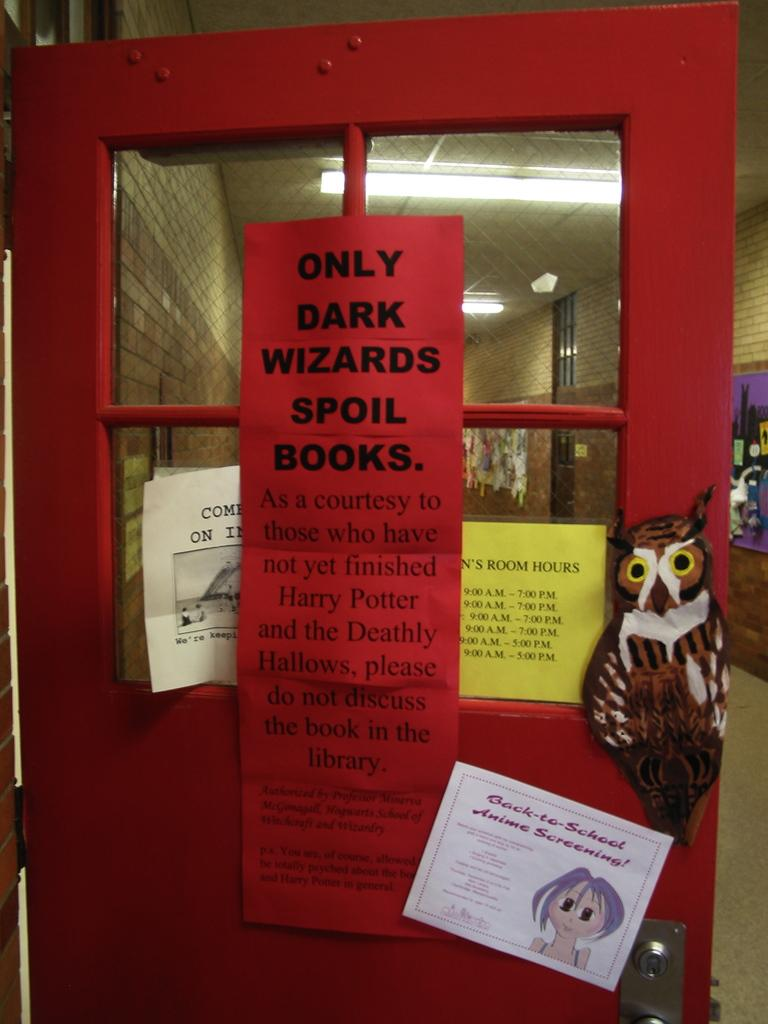<image>
Write a terse but informative summary of the picture. Red door with a owl that contains a only dark wizards spoil books sign 